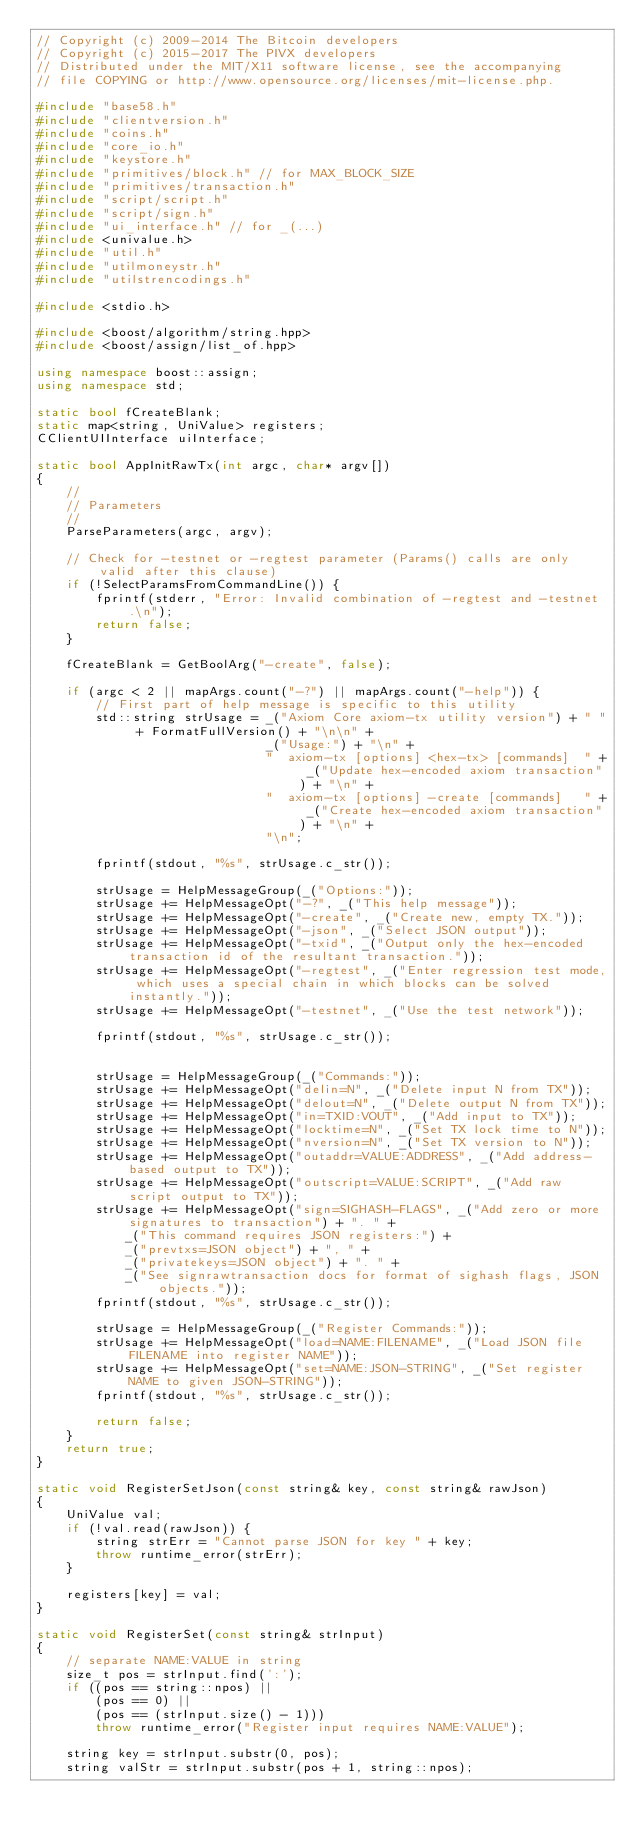Convert code to text. <code><loc_0><loc_0><loc_500><loc_500><_C++_>// Copyright (c) 2009-2014 The Bitcoin developers
// Copyright (c) 2015-2017 The PIVX developers
// Distributed under the MIT/X11 software license, see the accompanying
// file COPYING or http://www.opensource.org/licenses/mit-license.php.

#include "base58.h"
#include "clientversion.h"
#include "coins.h"
#include "core_io.h"
#include "keystore.h"
#include "primitives/block.h" // for MAX_BLOCK_SIZE
#include "primitives/transaction.h"
#include "script/script.h"
#include "script/sign.h"
#include "ui_interface.h" // for _(...)
#include <univalue.h>
#include "util.h"
#include "utilmoneystr.h"
#include "utilstrencodings.h"

#include <stdio.h>

#include <boost/algorithm/string.hpp>
#include <boost/assign/list_of.hpp>

using namespace boost::assign;
using namespace std;

static bool fCreateBlank;
static map<string, UniValue> registers;
CClientUIInterface uiInterface;

static bool AppInitRawTx(int argc, char* argv[])
{
    //
    // Parameters
    //
    ParseParameters(argc, argv);

    // Check for -testnet or -regtest parameter (Params() calls are only valid after this clause)
    if (!SelectParamsFromCommandLine()) {
        fprintf(stderr, "Error: Invalid combination of -regtest and -testnet.\n");
        return false;
    }

    fCreateBlank = GetBoolArg("-create", false);

    if (argc < 2 || mapArgs.count("-?") || mapArgs.count("-help")) {
        // First part of help message is specific to this utility
        std::string strUsage = _("Axiom Core axiom-tx utility version") + " " + FormatFullVersion() + "\n\n" +
                               _("Usage:") + "\n" +
                               "  axiom-tx [options] <hex-tx> [commands]  " + _("Update hex-encoded axiom transaction") + "\n" +
                               "  axiom-tx [options] -create [commands]   " + _("Create hex-encoded axiom transaction") + "\n" +
                               "\n";

        fprintf(stdout, "%s", strUsage.c_str());

        strUsage = HelpMessageGroup(_("Options:"));
        strUsage += HelpMessageOpt("-?", _("This help message"));
        strUsage += HelpMessageOpt("-create", _("Create new, empty TX."));
        strUsage += HelpMessageOpt("-json", _("Select JSON output"));
        strUsage += HelpMessageOpt("-txid", _("Output only the hex-encoded transaction id of the resultant transaction."));
        strUsage += HelpMessageOpt("-regtest", _("Enter regression test mode, which uses a special chain in which blocks can be solved instantly."));
        strUsage += HelpMessageOpt("-testnet", _("Use the test network"));

        fprintf(stdout, "%s", strUsage.c_str());


        strUsage = HelpMessageGroup(_("Commands:"));
        strUsage += HelpMessageOpt("delin=N", _("Delete input N from TX"));
        strUsage += HelpMessageOpt("delout=N", _("Delete output N from TX"));
        strUsage += HelpMessageOpt("in=TXID:VOUT", _("Add input to TX"));
        strUsage += HelpMessageOpt("locktime=N", _("Set TX lock time to N"));
        strUsage += HelpMessageOpt("nversion=N", _("Set TX version to N"));
        strUsage += HelpMessageOpt("outaddr=VALUE:ADDRESS", _("Add address-based output to TX"));
        strUsage += HelpMessageOpt("outscript=VALUE:SCRIPT", _("Add raw script output to TX"));
        strUsage += HelpMessageOpt("sign=SIGHASH-FLAGS", _("Add zero or more signatures to transaction") + ". " +
            _("This command requires JSON registers:") +
            _("prevtxs=JSON object") + ", " +
            _("privatekeys=JSON object") + ". " +
            _("See signrawtransaction docs for format of sighash flags, JSON objects."));
        fprintf(stdout, "%s", strUsage.c_str());

        strUsage = HelpMessageGroup(_("Register Commands:"));
        strUsage += HelpMessageOpt("load=NAME:FILENAME", _("Load JSON file FILENAME into register NAME"));
        strUsage += HelpMessageOpt("set=NAME:JSON-STRING", _("Set register NAME to given JSON-STRING"));
        fprintf(stdout, "%s", strUsage.c_str());

        return false;
    }
    return true;
}

static void RegisterSetJson(const string& key, const string& rawJson)
{
    UniValue val;
    if (!val.read(rawJson)) {
        string strErr = "Cannot parse JSON for key " + key;
        throw runtime_error(strErr);
    }

    registers[key] = val;
}

static void RegisterSet(const string& strInput)
{
    // separate NAME:VALUE in string
    size_t pos = strInput.find(':');
    if ((pos == string::npos) ||
        (pos == 0) ||
        (pos == (strInput.size() - 1)))
        throw runtime_error("Register input requires NAME:VALUE");

    string key = strInput.substr(0, pos);
    string valStr = strInput.substr(pos + 1, string::npos);
</code> 